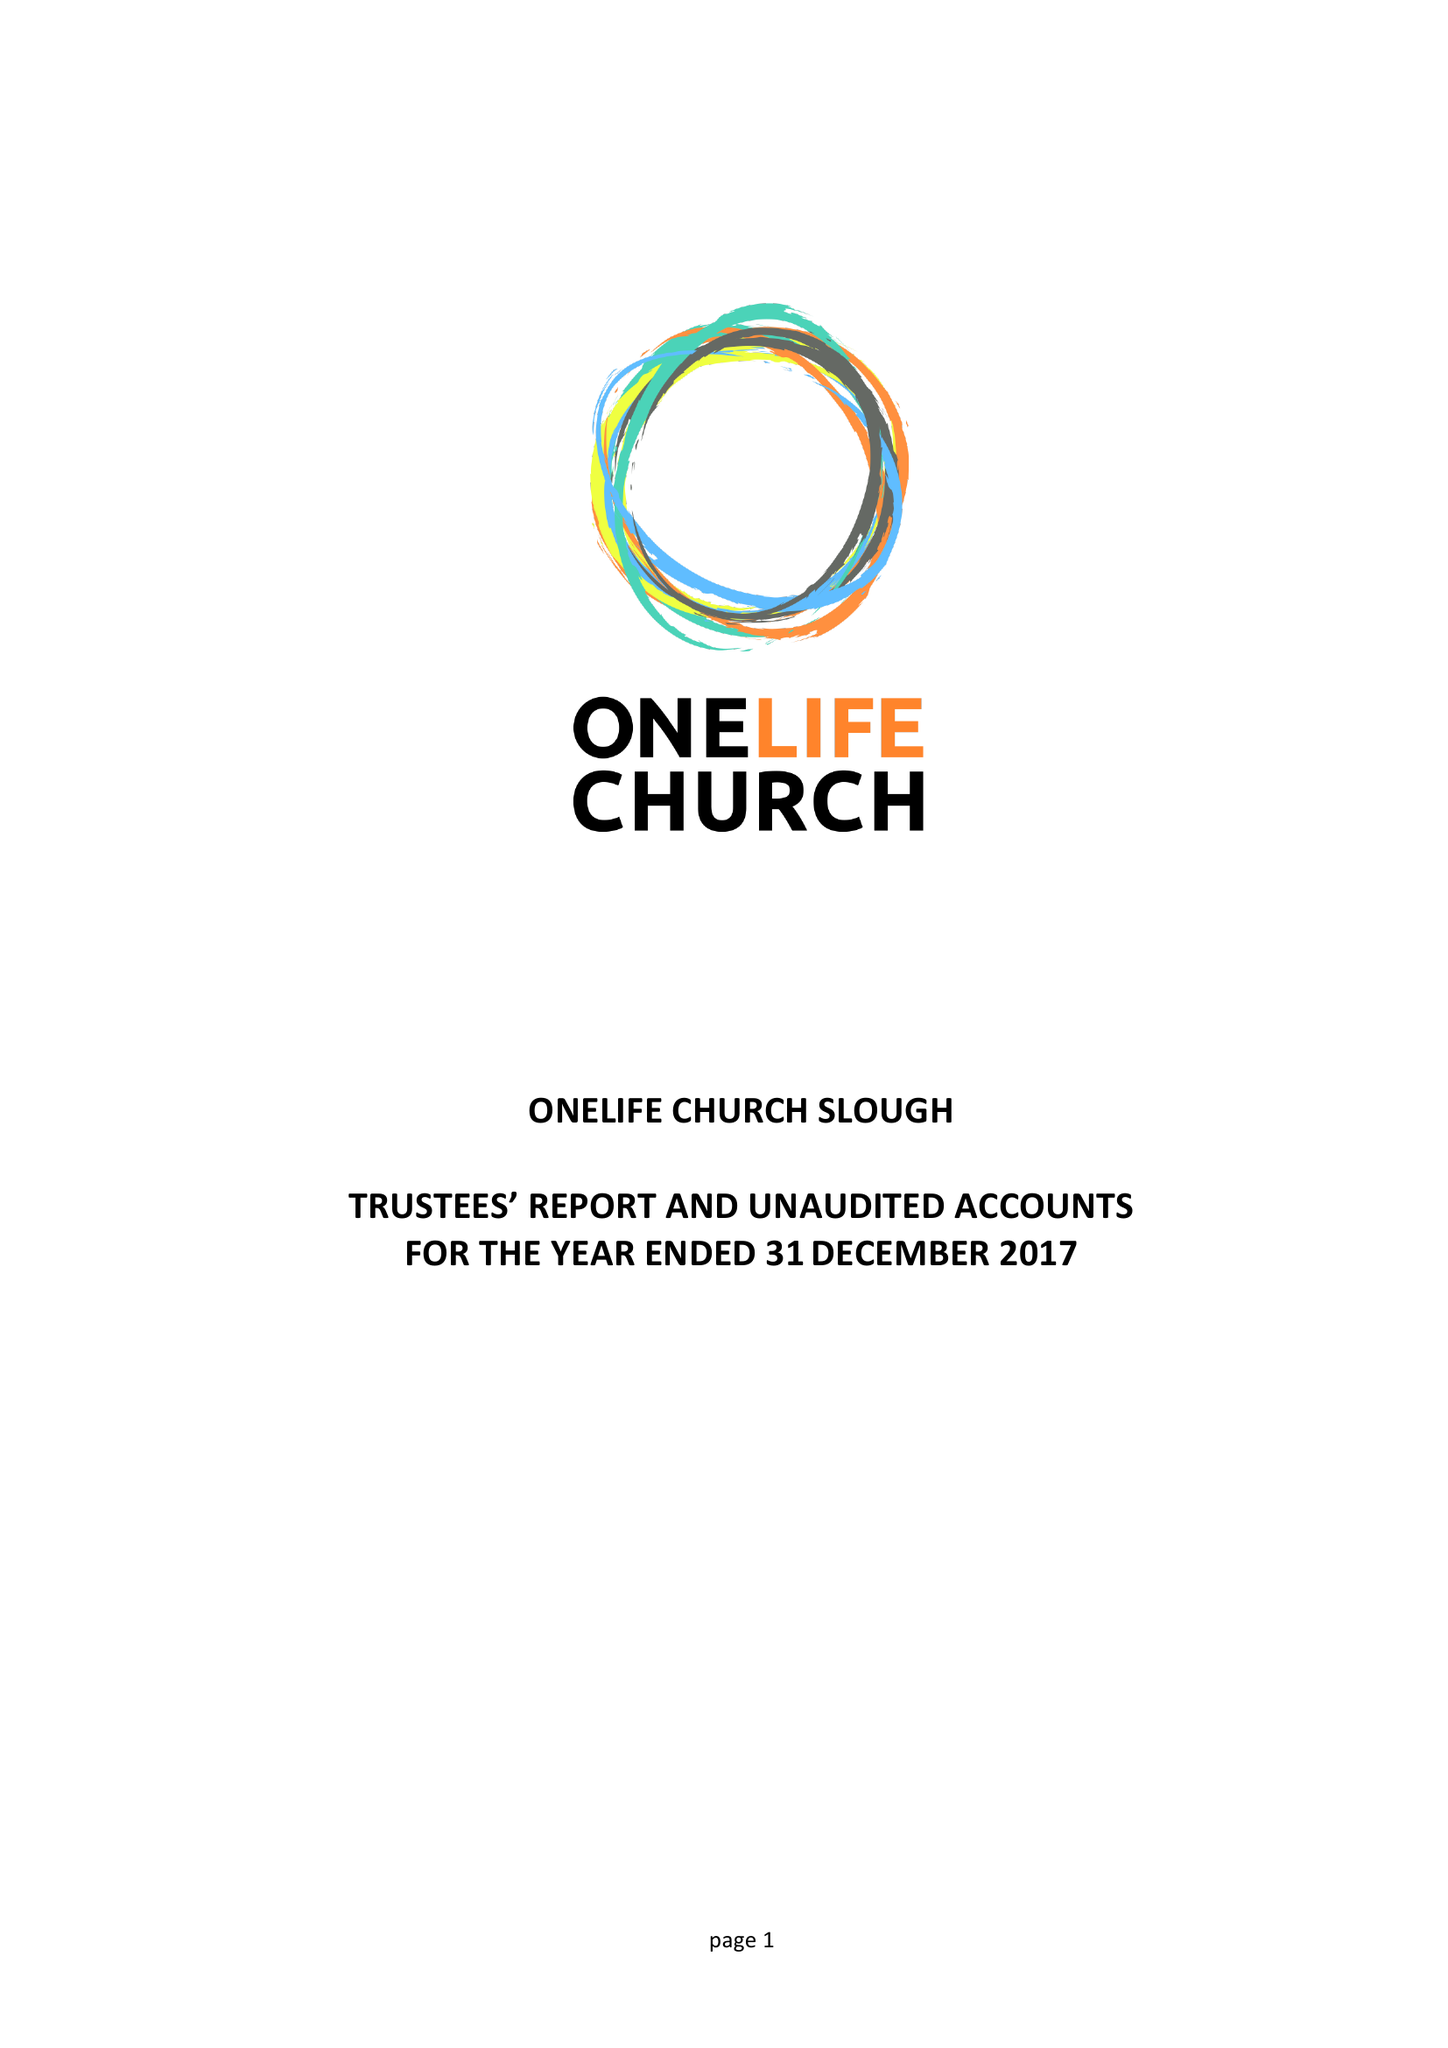What is the value for the spending_annually_in_british_pounds?
Answer the question using a single word or phrase. 33904.00 